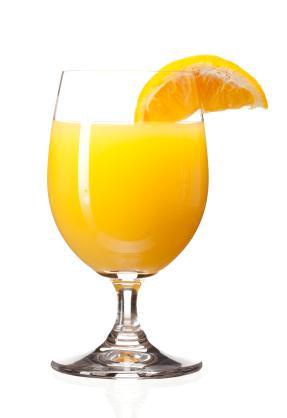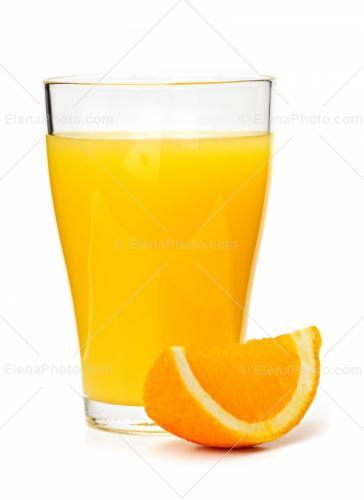The first image is the image on the left, the second image is the image on the right. Considering the images on both sides, is "Each image includes one glass containing an orange beverage and one wedge of orange." valid? Answer yes or no. Yes. The first image is the image on the left, the second image is the image on the right. Given the left and right images, does the statement "At least one of the oranges still has its stem and leaves attached to it." hold true? Answer yes or no. No. 